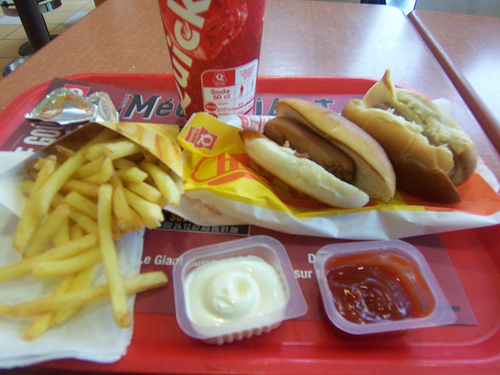Read all the text in this image. Me GO D sur CH 